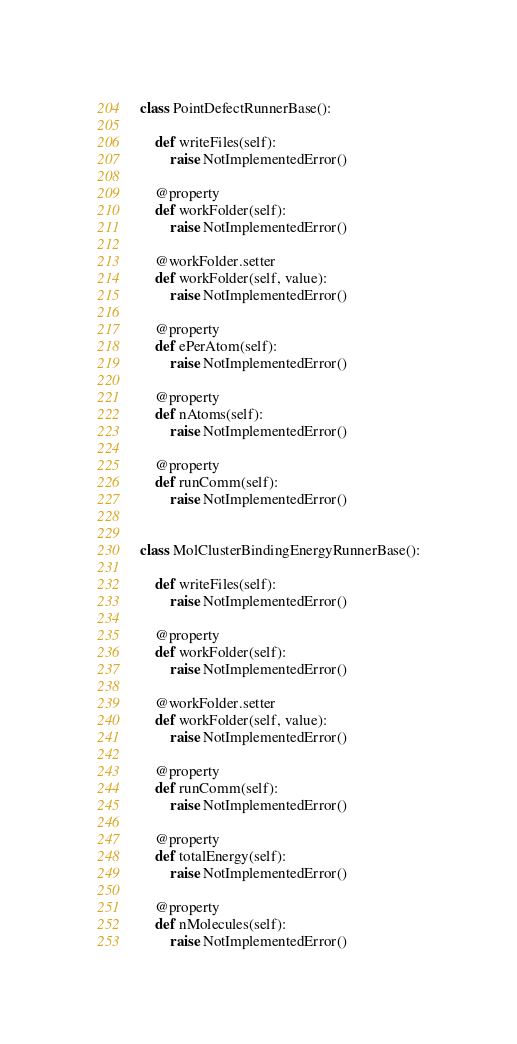<code> <loc_0><loc_0><loc_500><loc_500><_Python_>

class PointDefectRunnerBase():

	def writeFiles(self):
		raise NotImplementedError()

	@property
	def workFolder(self):
		raise NotImplementedError()

	@workFolder.setter
	def workFolder(self, value):
		raise NotImplementedError()

	@property
	def ePerAtom(self):
		raise NotImplementedError()

	@property
	def nAtoms(self):
		raise NotImplementedError()

	@property
	def runComm(self):
		raise NotImplementedError()


class MolClusterBindingEnergyRunnerBase():

	def writeFiles(self):
		raise NotImplementedError()

	@property
	def workFolder(self):
		raise NotImplementedError()

	@workFolder.setter
	def workFolder(self, value):
		raise NotImplementedError()

	@property
	def runComm(self):
		raise NotImplementedError()

	@property
	def totalEnergy(self):
		raise NotImplementedError()

	@property
	def nMolecules(self):
		raise NotImplementedError()


</code> 